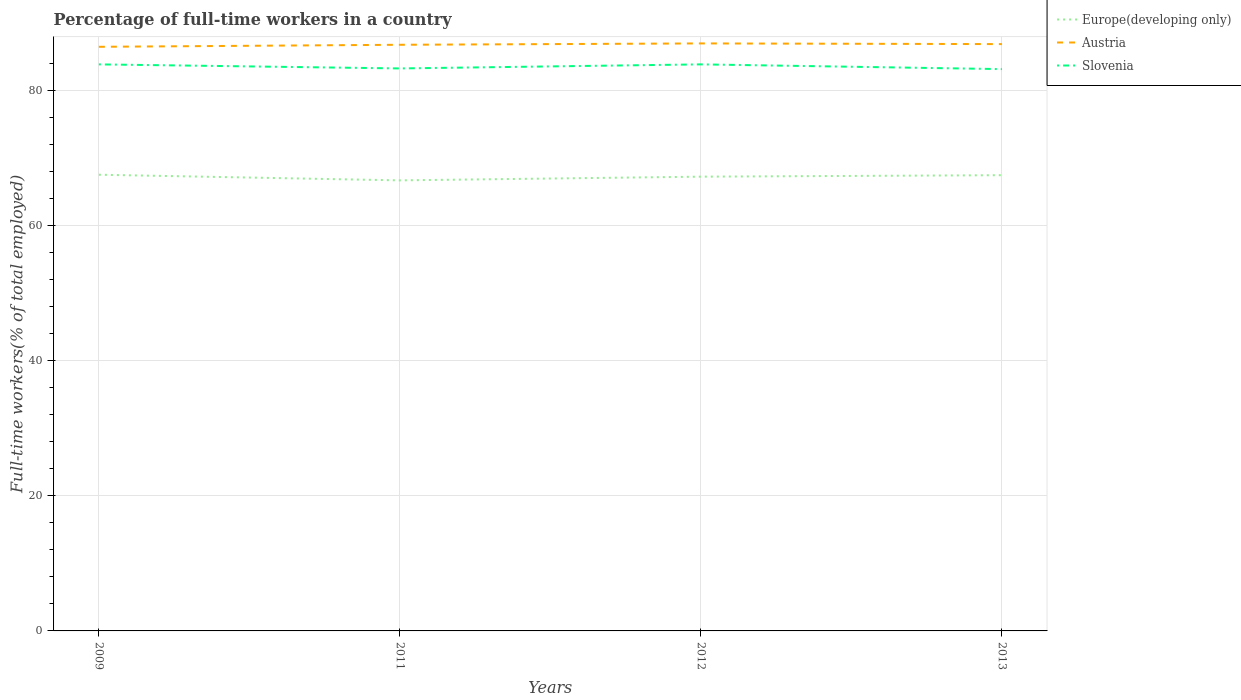Across all years, what is the maximum percentage of full-time workers in Slovenia?
Make the answer very short. 83.1. In which year was the percentage of full-time workers in Slovenia maximum?
Offer a very short reply. 2013. What is the total percentage of full-time workers in Slovenia in the graph?
Your response must be concise. 0.7. What is the difference between the highest and the second highest percentage of full-time workers in Slovenia?
Offer a terse response. 0.7. Is the percentage of full-time workers in Slovenia strictly greater than the percentage of full-time workers in Austria over the years?
Your answer should be very brief. Yes. How many lines are there?
Keep it short and to the point. 3. Where does the legend appear in the graph?
Keep it short and to the point. Top right. What is the title of the graph?
Your answer should be very brief. Percentage of full-time workers in a country. Does "Guatemala" appear as one of the legend labels in the graph?
Offer a terse response. No. What is the label or title of the X-axis?
Provide a short and direct response. Years. What is the label or title of the Y-axis?
Keep it short and to the point. Full-time workers(% of total employed). What is the Full-time workers(% of total employed) of Europe(developing only) in 2009?
Ensure brevity in your answer.  67.48. What is the Full-time workers(% of total employed) of Austria in 2009?
Your response must be concise. 86.4. What is the Full-time workers(% of total employed) of Slovenia in 2009?
Give a very brief answer. 83.8. What is the Full-time workers(% of total employed) of Europe(developing only) in 2011?
Offer a terse response. 66.64. What is the Full-time workers(% of total employed) in Austria in 2011?
Your answer should be compact. 86.7. What is the Full-time workers(% of total employed) of Slovenia in 2011?
Your answer should be very brief. 83.2. What is the Full-time workers(% of total employed) of Europe(developing only) in 2012?
Make the answer very short. 67.19. What is the Full-time workers(% of total employed) of Austria in 2012?
Keep it short and to the point. 86.9. What is the Full-time workers(% of total employed) of Slovenia in 2012?
Offer a terse response. 83.8. What is the Full-time workers(% of total employed) in Europe(developing only) in 2013?
Provide a short and direct response. 67.41. What is the Full-time workers(% of total employed) in Austria in 2013?
Provide a short and direct response. 86.8. What is the Full-time workers(% of total employed) in Slovenia in 2013?
Your response must be concise. 83.1. Across all years, what is the maximum Full-time workers(% of total employed) of Europe(developing only)?
Your response must be concise. 67.48. Across all years, what is the maximum Full-time workers(% of total employed) of Austria?
Provide a short and direct response. 86.9. Across all years, what is the maximum Full-time workers(% of total employed) in Slovenia?
Keep it short and to the point. 83.8. Across all years, what is the minimum Full-time workers(% of total employed) in Europe(developing only)?
Ensure brevity in your answer.  66.64. Across all years, what is the minimum Full-time workers(% of total employed) of Austria?
Provide a succinct answer. 86.4. Across all years, what is the minimum Full-time workers(% of total employed) of Slovenia?
Keep it short and to the point. 83.1. What is the total Full-time workers(% of total employed) of Europe(developing only) in the graph?
Provide a short and direct response. 268.72. What is the total Full-time workers(% of total employed) of Austria in the graph?
Provide a short and direct response. 346.8. What is the total Full-time workers(% of total employed) of Slovenia in the graph?
Give a very brief answer. 333.9. What is the difference between the Full-time workers(% of total employed) in Europe(developing only) in 2009 and that in 2011?
Provide a succinct answer. 0.83. What is the difference between the Full-time workers(% of total employed) in Austria in 2009 and that in 2011?
Provide a short and direct response. -0.3. What is the difference between the Full-time workers(% of total employed) of Slovenia in 2009 and that in 2011?
Keep it short and to the point. 0.6. What is the difference between the Full-time workers(% of total employed) in Europe(developing only) in 2009 and that in 2012?
Give a very brief answer. 0.29. What is the difference between the Full-time workers(% of total employed) in Austria in 2009 and that in 2012?
Your answer should be compact. -0.5. What is the difference between the Full-time workers(% of total employed) of Slovenia in 2009 and that in 2012?
Provide a short and direct response. 0. What is the difference between the Full-time workers(% of total employed) of Europe(developing only) in 2009 and that in 2013?
Ensure brevity in your answer.  0.07. What is the difference between the Full-time workers(% of total employed) in Europe(developing only) in 2011 and that in 2012?
Offer a very short reply. -0.55. What is the difference between the Full-time workers(% of total employed) in Europe(developing only) in 2011 and that in 2013?
Offer a very short reply. -0.77. What is the difference between the Full-time workers(% of total employed) in Austria in 2011 and that in 2013?
Offer a terse response. -0.1. What is the difference between the Full-time workers(% of total employed) in Slovenia in 2011 and that in 2013?
Give a very brief answer. 0.1. What is the difference between the Full-time workers(% of total employed) of Europe(developing only) in 2012 and that in 2013?
Make the answer very short. -0.22. What is the difference between the Full-time workers(% of total employed) of Slovenia in 2012 and that in 2013?
Your answer should be compact. 0.7. What is the difference between the Full-time workers(% of total employed) in Europe(developing only) in 2009 and the Full-time workers(% of total employed) in Austria in 2011?
Offer a very short reply. -19.22. What is the difference between the Full-time workers(% of total employed) in Europe(developing only) in 2009 and the Full-time workers(% of total employed) in Slovenia in 2011?
Give a very brief answer. -15.72. What is the difference between the Full-time workers(% of total employed) in Europe(developing only) in 2009 and the Full-time workers(% of total employed) in Austria in 2012?
Your answer should be very brief. -19.42. What is the difference between the Full-time workers(% of total employed) of Europe(developing only) in 2009 and the Full-time workers(% of total employed) of Slovenia in 2012?
Give a very brief answer. -16.32. What is the difference between the Full-time workers(% of total employed) in Austria in 2009 and the Full-time workers(% of total employed) in Slovenia in 2012?
Your answer should be compact. 2.6. What is the difference between the Full-time workers(% of total employed) in Europe(developing only) in 2009 and the Full-time workers(% of total employed) in Austria in 2013?
Your answer should be compact. -19.32. What is the difference between the Full-time workers(% of total employed) in Europe(developing only) in 2009 and the Full-time workers(% of total employed) in Slovenia in 2013?
Offer a terse response. -15.62. What is the difference between the Full-time workers(% of total employed) in Europe(developing only) in 2011 and the Full-time workers(% of total employed) in Austria in 2012?
Provide a short and direct response. -20.26. What is the difference between the Full-time workers(% of total employed) in Europe(developing only) in 2011 and the Full-time workers(% of total employed) in Slovenia in 2012?
Your answer should be very brief. -17.16. What is the difference between the Full-time workers(% of total employed) of Europe(developing only) in 2011 and the Full-time workers(% of total employed) of Austria in 2013?
Ensure brevity in your answer.  -20.16. What is the difference between the Full-time workers(% of total employed) in Europe(developing only) in 2011 and the Full-time workers(% of total employed) in Slovenia in 2013?
Provide a short and direct response. -16.46. What is the difference between the Full-time workers(% of total employed) in Austria in 2011 and the Full-time workers(% of total employed) in Slovenia in 2013?
Ensure brevity in your answer.  3.6. What is the difference between the Full-time workers(% of total employed) in Europe(developing only) in 2012 and the Full-time workers(% of total employed) in Austria in 2013?
Offer a very short reply. -19.61. What is the difference between the Full-time workers(% of total employed) in Europe(developing only) in 2012 and the Full-time workers(% of total employed) in Slovenia in 2013?
Your response must be concise. -15.91. What is the difference between the Full-time workers(% of total employed) of Austria in 2012 and the Full-time workers(% of total employed) of Slovenia in 2013?
Your response must be concise. 3.8. What is the average Full-time workers(% of total employed) in Europe(developing only) per year?
Provide a short and direct response. 67.18. What is the average Full-time workers(% of total employed) in Austria per year?
Provide a succinct answer. 86.7. What is the average Full-time workers(% of total employed) in Slovenia per year?
Offer a terse response. 83.47. In the year 2009, what is the difference between the Full-time workers(% of total employed) of Europe(developing only) and Full-time workers(% of total employed) of Austria?
Provide a succinct answer. -18.92. In the year 2009, what is the difference between the Full-time workers(% of total employed) of Europe(developing only) and Full-time workers(% of total employed) of Slovenia?
Ensure brevity in your answer.  -16.32. In the year 2011, what is the difference between the Full-time workers(% of total employed) of Europe(developing only) and Full-time workers(% of total employed) of Austria?
Ensure brevity in your answer.  -20.06. In the year 2011, what is the difference between the Full-time workers(% of total employed) of Europe(developing only) and Full-time workers(% of total employed) of Slovenia?
Offer a terse response. -16.56. In the year 2011, what is the difference between the Full-time workers(% of total employed) of Austria and Full-time workers(% of total employed) of Slovenia?
Ensure brevity in your answer.  3.5. In the year 2012, what is the difference between the Full-time workers(% of total employed) in Europe(developing only) and Full-time workers(% of total employed) in Austria?
Provide a succinct answer. -19.71. In the year 2012, what is the difference between the Full-time workers(% of total employed) of Europe(developing only) and Full-time workers(% of total employed) of Slovenia?
Provide a succinct answer. -16.61. In the year 2013, what is the difference between the Full-time workers(% of total employed) in Europe(developing only) and Full-time workers(% of total employed) in Austria?
Provide a short and direct response. -19.39. In the year 2013, what is the difference between the Full-time workers(% of total employed) in Europe(developing only) and Full-time workers(% of total employed) in Slovenia?
Provide a short and direct response. -15.69. What is the ratio of the Full-time workers(% of total employed) of Europe(developing only) in 2009 to that in 2011?
Provide a short and direct response. 1.01. What is the ratio of the Full-time workers(% of total employed) of Slovenia in 2009 to that in 2011?
Ensure brevity in your answer.  1.01. What is the ratio of the Full-time workers(% of total employed) in Austria in 2009 to that in 2012?
Provide a short and direct response. 0.99. What is the ratio of the Full-time workers(% of total employed) of Slovenia in 2009 to that in 2012?
Give a very brief answer. 1. What is the ratio of the Full-time workers(% of total employed) of Europe(developing only) in 2009 to that in 2013?
Provide a succinct answer. 1. What is the ratio of the Full-time workers(% of total employed) of Slovenia in 2009 to that in 2013?
Keep it short and to the point. 1.01. What is the ratio of the Full-time workers(% of total employed) in Austria in 2011 to that in 2012?
Ensure brevity in your answer.  1. What is the ratio of the Full-time workers(% of total employed) in Slovenia in 2011 to that in 2012?
Keep it short and to the point. 0.99. What is the ratio of the Full-time workers(% of total employed) of Austria in 2011 to that in 2013?
Your answer should be compact. 1. What is the ratio of the Full-time workers(% of total employed) of Austria in 2012 to that in 2013?
Your answer should be very brief. 1. What is the ratio of the Full-time workers(% of total employed) of Slovenia in 2012 to that in 2013?
Provide a short and direct response. 1.01. What is the difference between the highest and the second highest Full-time workers(% of total employed) in Europe(developing only)?
Offer a terse response. 0.07. What is the difference between the highest and the lowest Full-time workers(% of total employed) of Europe(developing only)?
Your answer should be very brief. 0.83. 